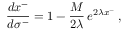<formula> <loc_0><loc_0><loc_500><loc_500>\frac { d x ^ { - } } { d \sigma ^ { - } } = 1 - \frac { M } { 2 \lambda } \, e ^ { 2 \lambda x ^ { - } } \, ,</formula> 